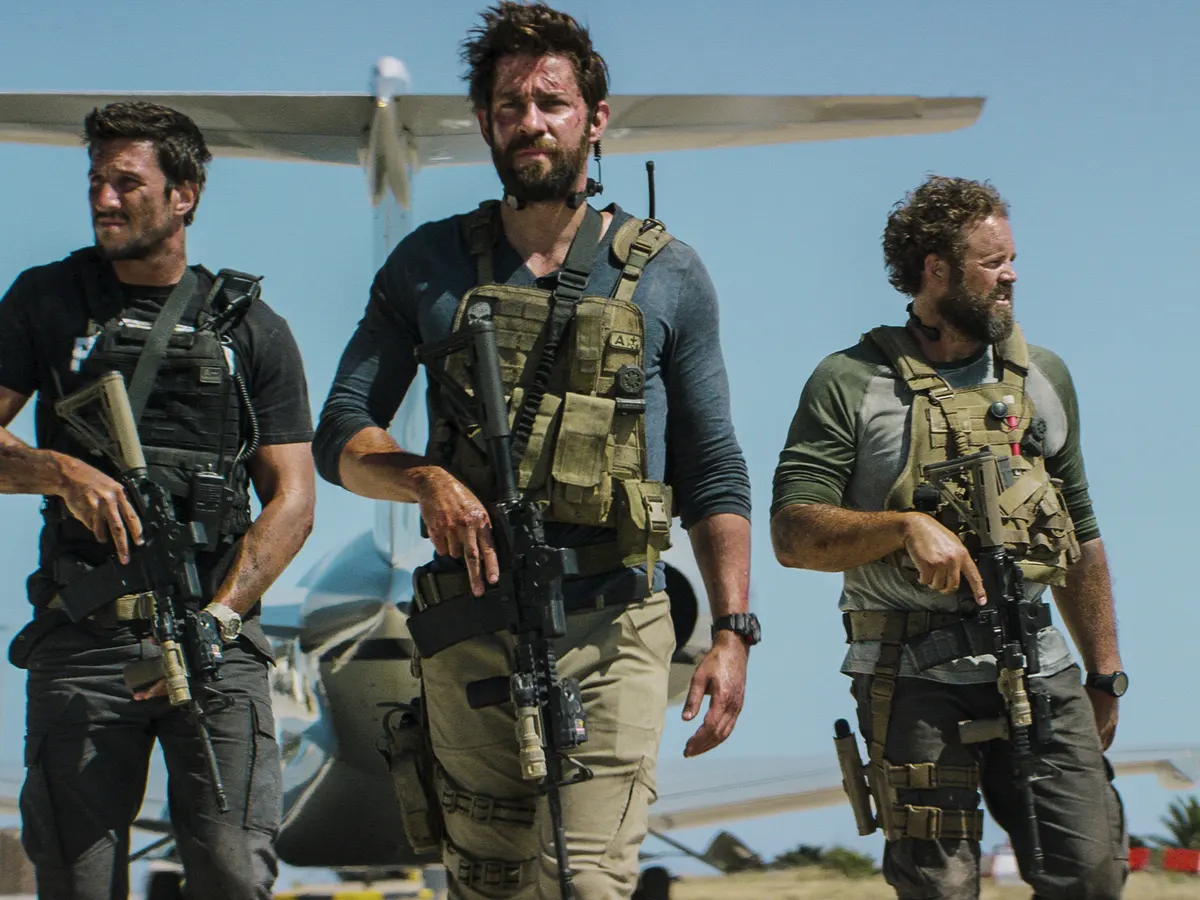What is the role of the airplane in the background relative to the individuals in the foreground? The small airplane in the background likely serves as the mode of transportation for the individuals. It could indicate that they have just arrived at their operation's location, or it could be their extraction point after completing a mission. Could the environment provide any additional clues about their mission? Yes, the arid terrain and open skies imply the mission might take place in a remote or desert-like area, possibly necessitating strategies that account for the challenging climate and expansive geography. 